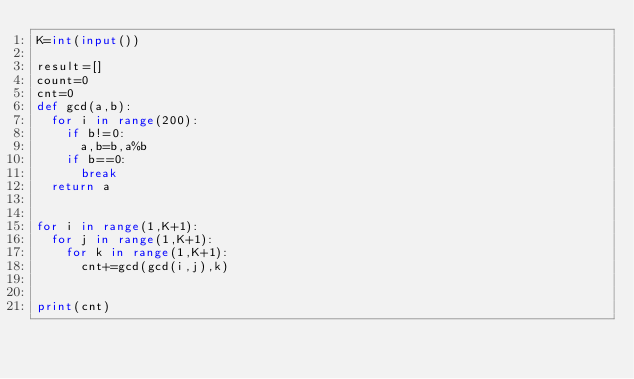Convert code to text. <code><loc_0><loc_0><loc_500><loc_500><_Python_>K=int(input())

result=[]
count=0
cnt=0
def gcd(a,b):
  for i in range(200):
    if b!=0:
      a,b=b,a%b
    if b==0:
      break
  return a

 
for i in range(1,K+1):
  for j in range(1,K+1):
    for k in range(1,K+1):
      cnt+=gcd(gcd(i,j),k)


print(cnt)
</code> 